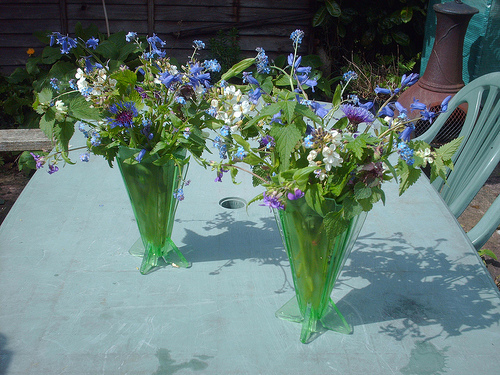Please provide the bounding box coordinate of the region this sentence describes: blue flower next to blue flower. The coordinates [0.4, 0.24, 0.45, 0.27] correspond to a part of the tabletop where two visually similar blue flowers can be seen close to each other, set against a verdant backdrop. 